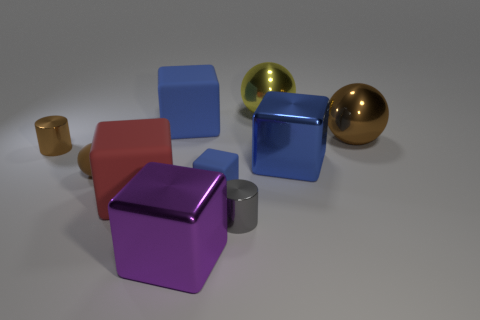There is a metallic thing that is both in front of the tiny matte sphere and left of the small gray shiny cylinder; what is its shape?
Offer a terse response. Cube. There is a cylinder behind the blue matte cube that is in front of the small brown metal cylinder; what is its size?
Provide a short and direct response. Small. How many other objects are there of the same color as the tiny ball?
Ensure brevity in your answer.  2. What is the material of the red thing?
Your answer should be compact. Rubber. Are there any small purple cylinders?
Provide a short and direct response. No. Is the number of small brown spheres that are behind the large yellow metal thing the same as the number of yellow balls?
Offer a very short reply. No. Is there anything else that has the same material as the big yellow sphere?
Give a very brief answer. Yes. What number of large objects are either green cylinders or metallic objects?
Your response must be concise. 4. There is a tiny object that is the same color as the small ball; what is its shape?
Keep it short and to the point. Cylinder. Are the big block that is behind the big blue metal object and the gray thing made of the same material?
Keep it short and to the point. No. 